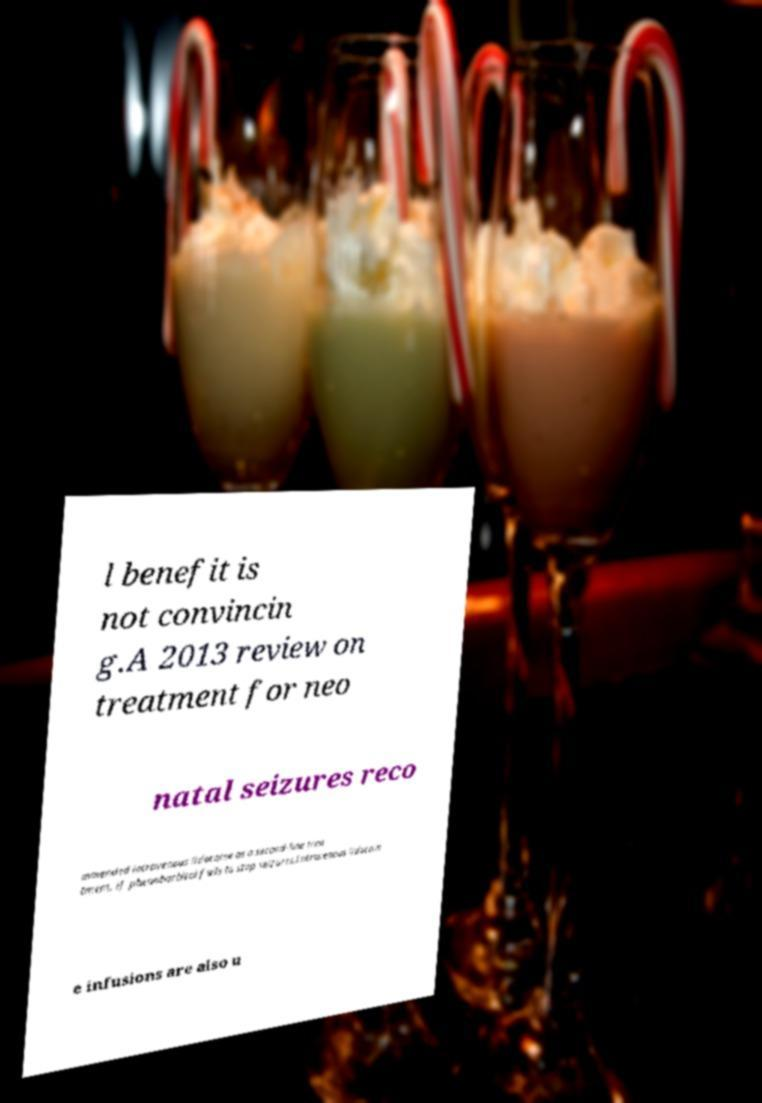For documentation purposes, I need the text within this image transcribed. Could you provide that? l benefit is not convincin g.A 2013 review on treatment for neo natal seizures reco mmended intravenous lidocaine as a second-line trea tment, if phenobarbital fails to stop seizures.Intravenous lidocain e infusions are also u 